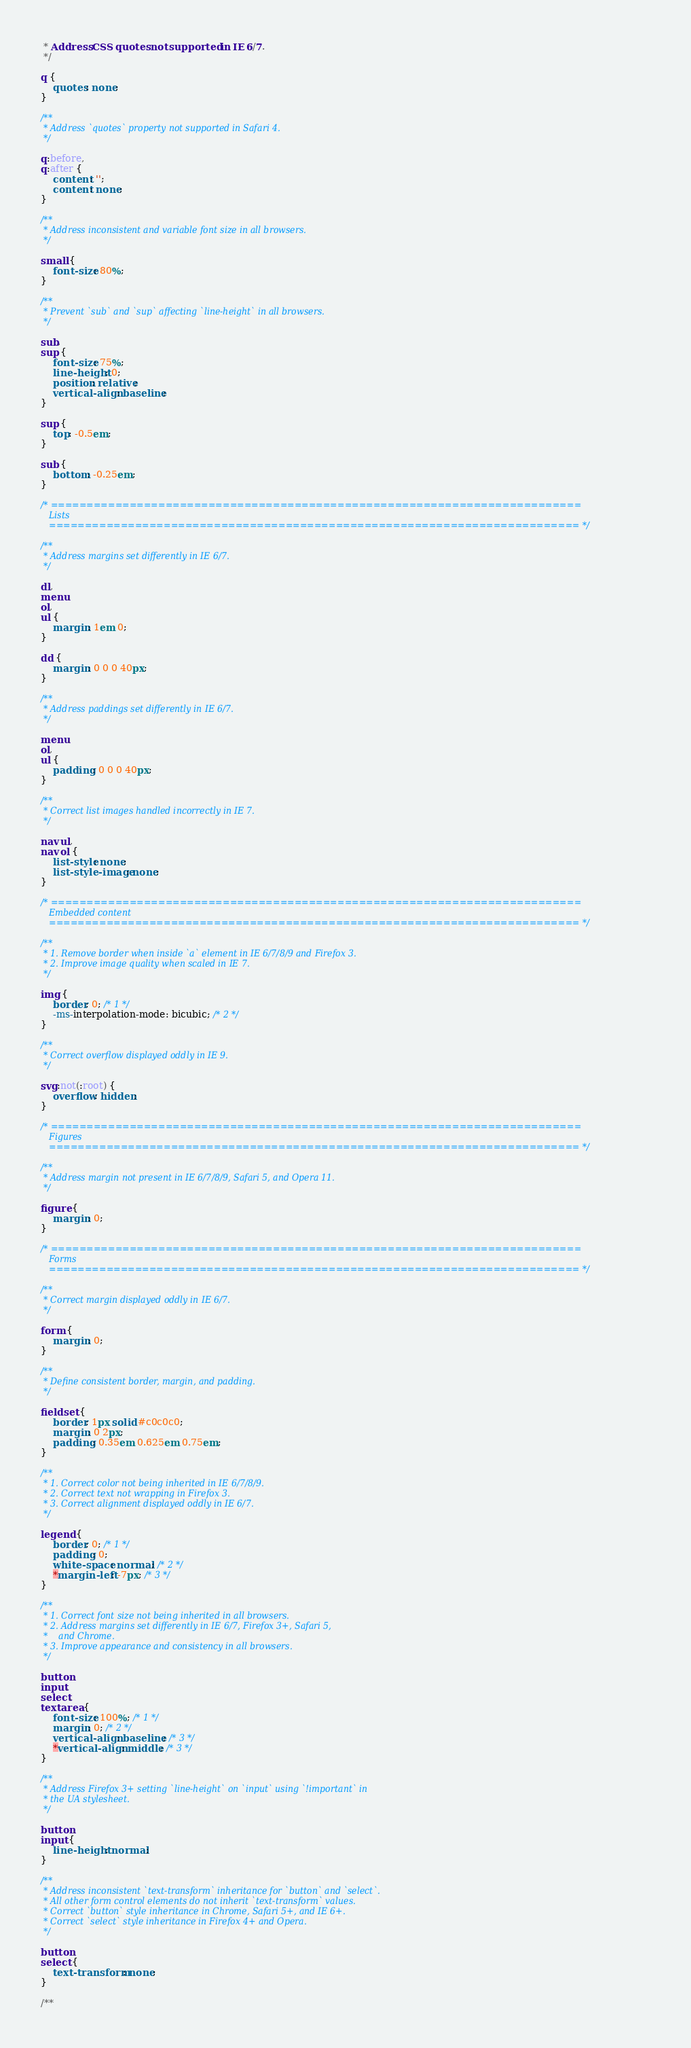Convert code to text. <code><loc_0><loc_0><loc_500><loc_500><_CSS_> * Address CSS quotes not supported in IE 6/7.
 */

q {
    quotes: none;
}

/**
 * Address `quotes` property not supported in Safari 4.
 */

q:before,
q:after {
    content: '';
    content: none;
}

/**
 * Address inconsistent and variable font size in all browsers.
 */

small {
    font-size: 80%;
}

/**
 * Prevent `sub` and `sup` affecting `line-height` in all browsers.
 */

sub,
sup {
    font-size: 75%;
    line-height: 0;
    position: relative;
    vertical-align: baseline;
}

sup {
    top: -0.5em;
}

sub {
    bottom: -0.25em;
}

/* ==========================================================================
   Lists
   ========================================================================== */

/**
 * Address margins set differently in IE 6/7.
 */

dl,
menu,
ol,
ul {
    margin: 1em 0;
}

dd {
    margin: 0 0 0 40px;
}

/**
 * Address paddings set differently in IE 6/7.
 */

menu,
ol,
ul {
    padding: 0 0 0 40px;
}

/**
 * Correct list images handled incorrectly in IE 7.
 */

nav ul,
nav ol {
    list-style: none;
    list-style-image: none;
}

/* ==========================================================================
   Embedded content
   ========================================================================== */

/**
 * 1. Remove border when inside `a` element in IE 6/7/8/9 and Firefox 3.
 * 2. Improve image quality when scaled in IE 7.
 */

img {
    border: 0; /* 1 */
    -ms-interpolation-mode: bicubic; /* 2 */
}

/**
 * Correct overflow displayed oddly in IE 9.
 */

svg:not(:root) {
    overflow: hidden;
}

/* ==========================================================================
   Figures
   ========================================================================== */

/**
 * Address margin not present in IE 6/7/8/9, Safari 5, and Opera 11.
 */

figure {
    margin: 0;
}

/* ==========================================================================
   Forms
   ========================================================================== */

/**
 * Correct margin displayed oddly in IE 6/7.
 */

form {
    margin: 0;
}

/**
 * Define consistent border, margin, and padding.
 */

fieldset {
    border: 1px solid #c0c0c0;
    margin: 0 2px;
    padding: 0.35em 0.625em 0.75em;
}

/**
 * 1. Correct color not being inherited in IE 6/7/8/9.
 * 2. Correct text not wrapping in Firefox 3.
 * 3. Correct alignment displayed oddly in IE 6/7.
 */

legend {
    border: 0; /* 1 */
    padding: 0;
    white-space: normal; /* 2 */
    *margin-left: -7px; /* 3 */
}

/**
 * 1. Correct font size not being inherited in all browsers.
 * 2. Address margins set differently in IE 6/7, Firefox 3+, Safari 5,
 *    and Chrome.
 * 3. Improve appearance and consistency in all browsers.
 */

button,
input,
select,
textarea {
    font-size: 100%; /* 1 */
    margin: 0; /* 2 */
    vertical-align: baseline; /* 3 */
    *vertical-align: middle; /* 3 */
}

/**
 * Address Firefox 3+ setting `line-height` on `input` using `!important` in
 * the UA stylesheet.
 */

button,
input {
    line-height: normal;
}

/**
 * Address inconsistent `text-transform` inheritance for `button` and `select`.
 * All other form control elements do not inherit `text-transform` values.
 * Correct `button` style inheritance in Chrome, Safari 5+, and IE 6+.
 * Correct `select` style inheritance in Firefox 4+ and Opera.
 */

button,
select {
    text-transform: none;
}

/**</code> 